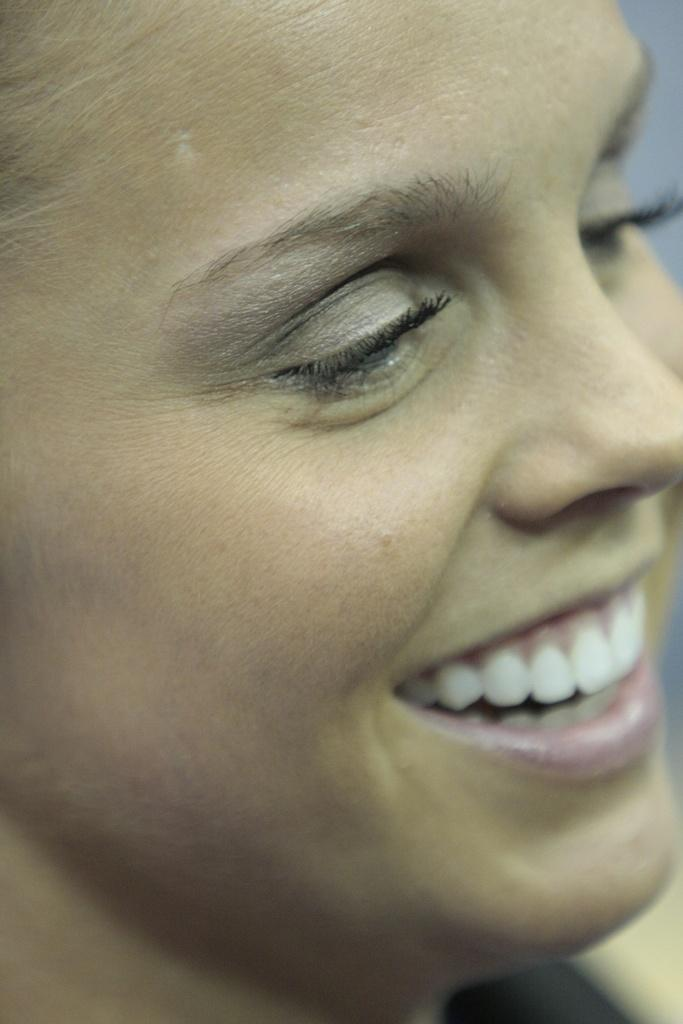What is the focus of the zoomed in picture? The image is a zoomed in picture of a woman. What is the woman doing in the picture? The woman is smiling in the picture. What type of rock can be seen in the background of the image? There is no rock present in the image; it is a zoomed in picture of a woman. What type of uniform is the fireman wearing in the image? There is no fireman present in the image; it is a zoomed in picture of a woman. 